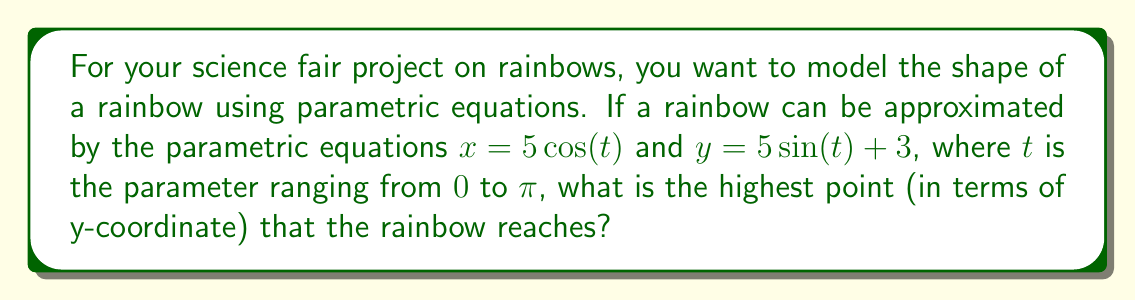Show me your answer to this math problem. Let's approach this step-by-step:

1) The parametric equations given are:
   $x = 5 \cos(t)$
   $y = 5 \sin(t) + 3$

2) To find the highest point of the rainbow, we need to find the maximum value of $y$.

3) The $y$ equation consists of two parts: $5 \sin(t)$ and a constant $3$.

4) The sine function $\sin(t)$ has a maximum value of 1, which occurs when $t = \frac{\pi}{2}$.

5) Therefore, the maximum value of $5 \sin(t)$ is $5 \cdot 1 = 5$.

6) Adding this to the constant 3, we get:

   $y_{max} = 5 \cdot 1 + 3 = 8$

7) We can verify this by plotting the parametric equations:

[asy]
import graph;
size(200,200);
real x(real t) {return 5*cos(t);}
real y(real t) {return 5*sin(t)+3;}
draw(graph(x,y,0,pi),blue);
dot((0,8),red);
label("(0,8)",(0,8),N,red);
xaxis("x");
yaxis("y");
[/asy]

8) The graph confirms that the highest point of the rainbow occurs at $(0,8)$.
Answer: The highest point of the rainbow is 8 units above the x-axis (i.e., $y = 8$). 